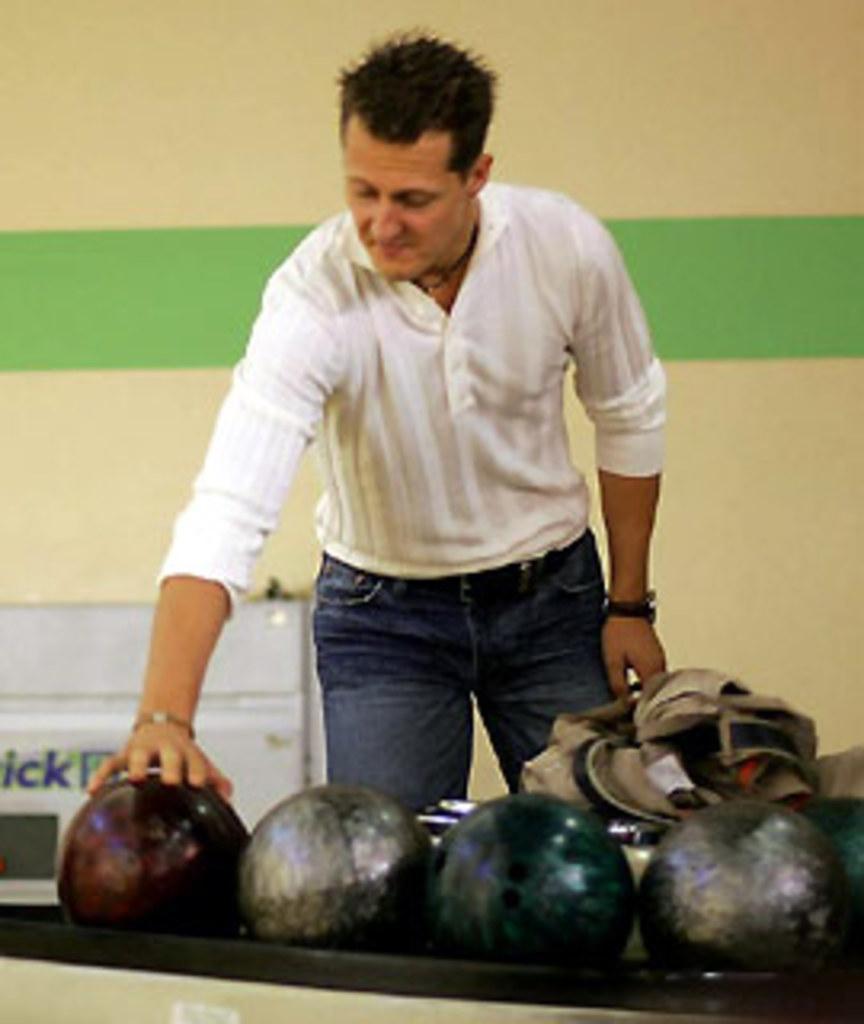Describe this image in one or two sentences. The person wearing white shirt is standing and placed his hand on a ball and there are few other balls beside it. 